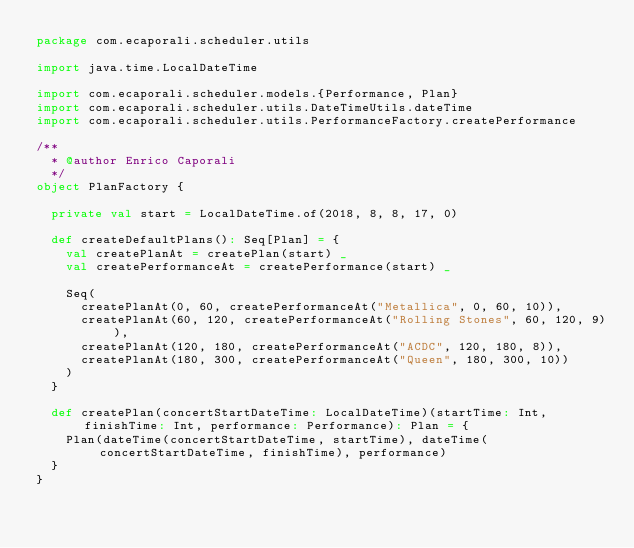Convert code to text. <code><loc_0><loc_0><loc_500><loc_500><_Scala_>package com.ecaporali.scheduler.utils

import java.time.LocalDateTime

import com.ecaporali.scheduler.models.{Performance, Plan}
import com.ecaporali.scheduler.utils.DateTimeUtils.dateTime
import com.ecaporali.scheduler.utils.PerformanceFactory.createPerformance

/**
  * @author Enrico Caporali
  */
object PlanFactory {

  private val start = LocalDateTime.of(2018, 8, 8, 17, 0)

  def createDefaultPlans(): Seq[Plan] = {
    val createPlanAt = createPlan(start) _
    val createPerformanceAt = createPerformance(start) _

    Seq(
      createPlanAt(0, 60, createPerformanceAt("Metallica", 0, 60, 10)),
      createPlanAt(60, 120, createPerformanceAt("Rolling Stones", 60, 120, 9)),
      createPlanAt(120, 180, createPerformanceAt("ACDC", 120, 180, 8)),
      createPlanAt(180, 300, createPerformanceAt("Queen", 180, 300, 10))
    )
  }

  def createPlan(concertStartDateTime: LocalDateTime)(startTime: Int, finishTime: Int, performance: Performance): Plan = {
    Plan(dateTime(concertStartDateTime, startTime), dateTime(concertStartDateTime, finishTime), performance)
  }
}
</code> 